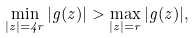Convert formula to latex. <formula><loc_0><loc_0><loc_500><loc_500>\min _ { | z | = 4 r } | g ( z ) | > \max _ { | z | = r } | g ( z ) | ,</formula> 